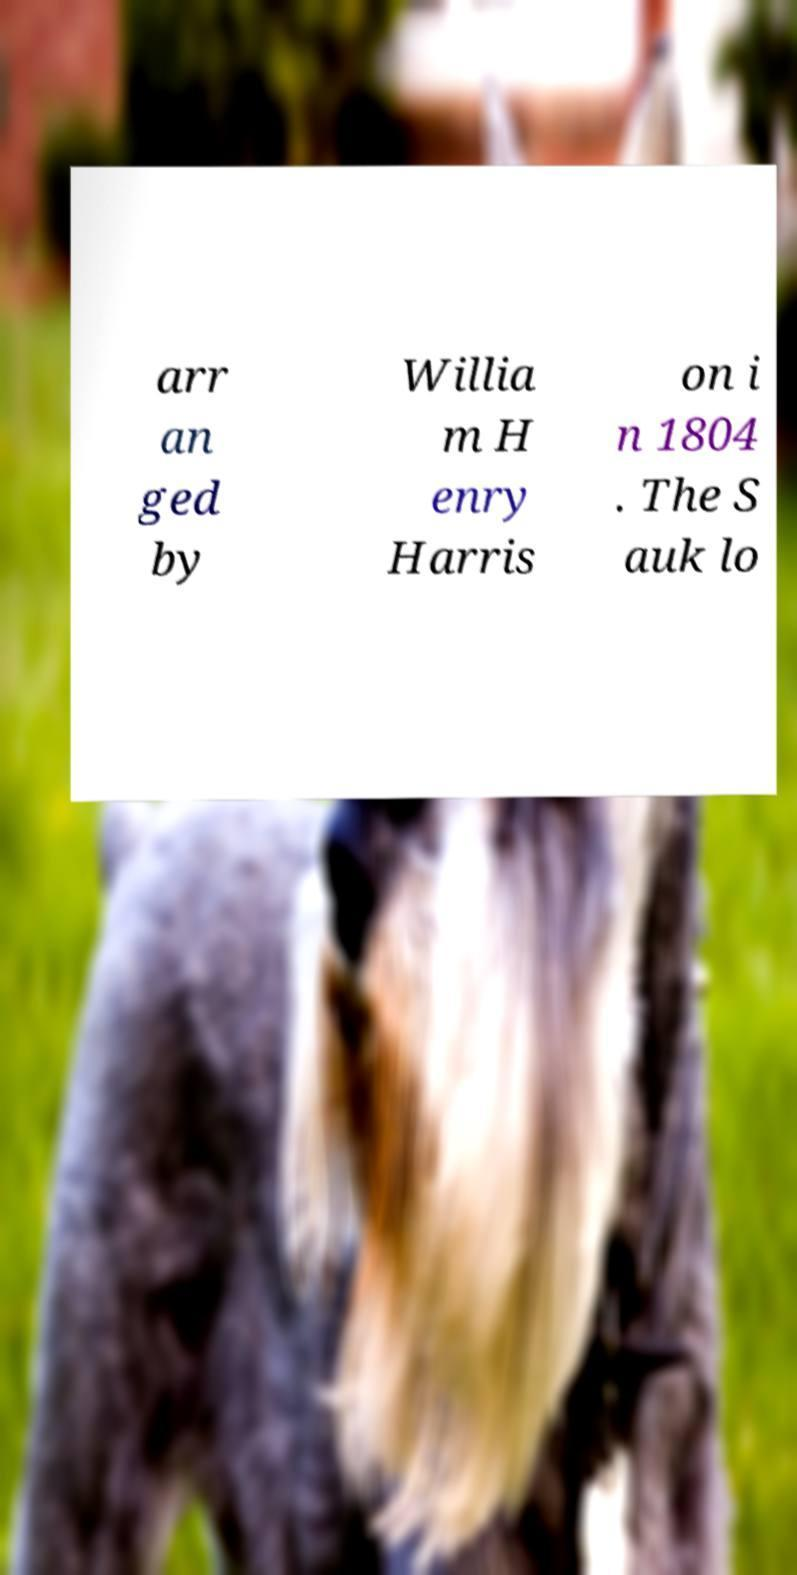There's text embedded in this image that I need extracted. Can you transcribe it verbatim? arr an ged by Willia m H enry Harris on i n 1804 . The S auk lo 